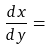Convert formula to latex. <formula><loc_0><loc_0><loc_500><loc_500>\frac { d x } { d y } =</formula> 